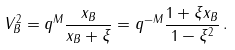<formula> <loc_0><loc_0><loc_500><loc_500>V _ { B } ^ { 2 } = q ^ { M } \frac { x _ { B } } { x _ { B } + \xi } = q ^ { - M } \frac { 1 + \xi x _ { B } } { 1 - \xi ^ { 2 } } \, .</formula> 